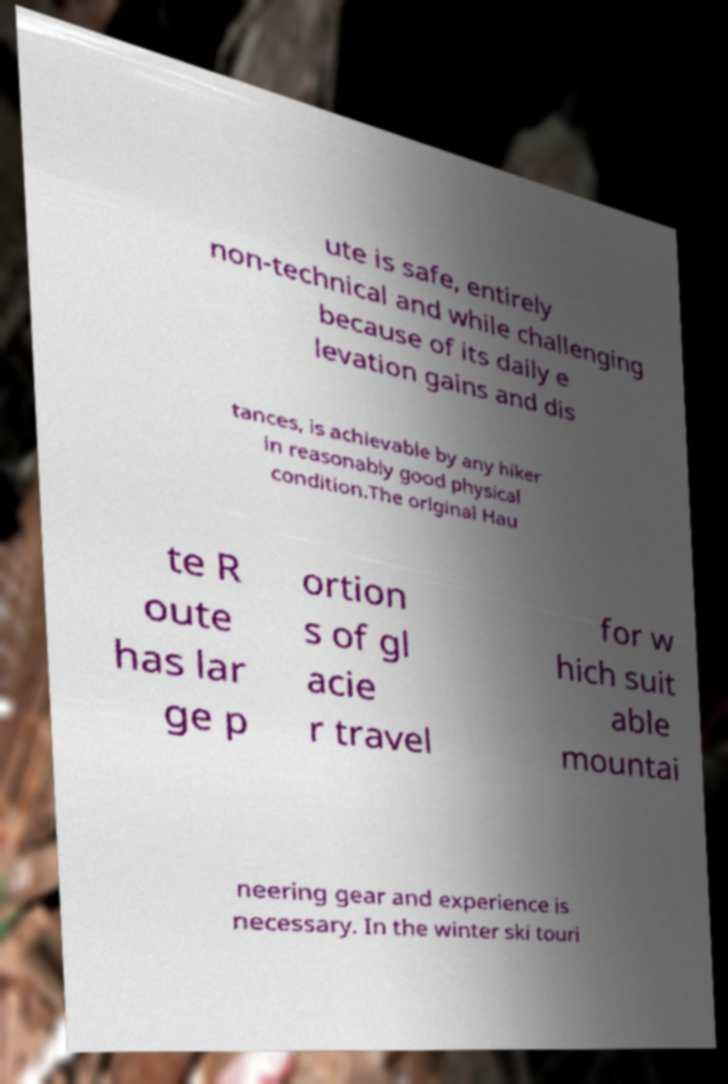For documentation purposes, I need the text within this image transcribed. Could you provide that? ute is safe, entirely non-technical and while challenging because of its daily e levation gains and dis tances, is achievable by any hiker in reasonably good physical condition.The original Hau te R oute has lar ge p ortion s of gl acie r travel for w hich suit able mountai neering gear and experience is necessary. In the winter ski touri 